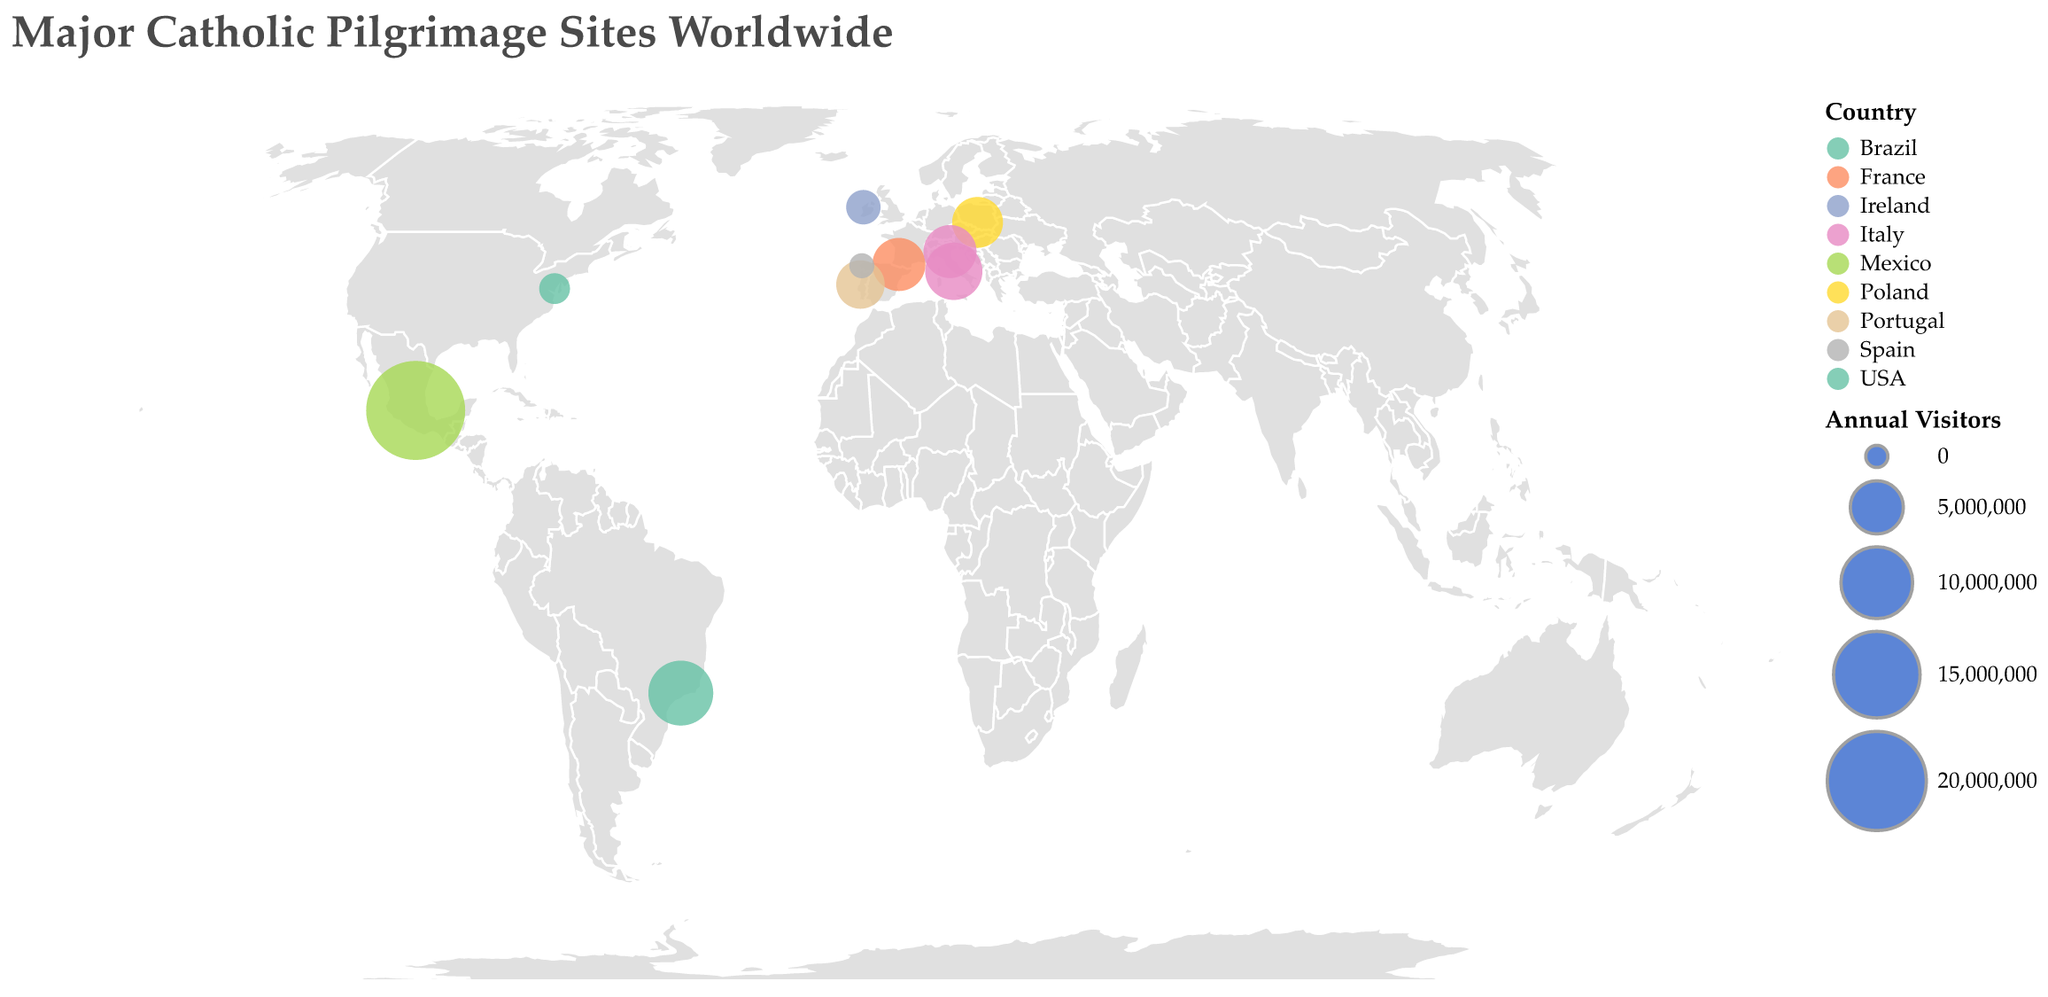What is the title of the plot? The title of the plot is often found at the top. Here, it is "Major Catholic Pilgrimage Sites Worldwide" as specified in the data provided.
Answer: Major Catholic Pilgrimage Sites Worldwide Which site has the highest number of annual visitors? By looking at the size of the circles in the plot, the largest circle would represent the site with the most visitors. According to the data, the Basilica of Our Lady of Guadalupe in Mexico has the largest annual visitors at 20,000,000.
Answer: Basilica of Our Lady of Guadalupe Which country has the most pilgrimage sites in the figure? Observing the color legend representing countries and counting the number of circles (pilgrimage sites) for each country helps in identifying this. Italy has two pilgrimage sites (Vatican City and Basilica of Saint Anthony).
Answer: Italy Which site receives more visitors, the Sanctuary of Fátima or the Sanctuary of Knock? Comparing the size of the circles or directly referring to the data values: Sanctuary of Fátima has 4,000,000 visitors, and Sanctuary of Knock has 1,500,000 visitors.
Answer: Sanctuary of Fátima What is the total number of annual visitors to the sites in Europe? Summing up the Annual_Visitors from the European sites (Vatican City, Sanctuary of Our Lady of Lourdes, Sanctuary of Fátima, Santiago de Compostela, Sanctuary of Knock, Shrine of Our Lady of Czestochowa, Basilica of Saint Anthony): 6,000,000 + 5,000,000 + 4,000,000 + 300,000 + 1,500,000 + 4,500,000 + 5,000,000 = 26,300,000.
Answer: 26,300,000 How does the annual visitor number of the Shrine of Our Lady of Aparecida compare to the Vatican City? Referring to the data values: Shrine of Our Lady of Aparecida has 8,000,000 visitors, while Vatican City has 6,000,000. Thus, the Shrine of Our Lady of Aparecida has 2,000,000 more visitors than Vatican City.
Answer: 2,000,000 more Identify the pilgrimage site in the Americas with the least annual visitors. Observing the data, the Basilica of the National Shrine of the Immaculate Conception (USA) has the least visitors in the Americas: 1,000,000 annual visitors.
Answer: Basilica of the National Shrine of the Immaculate Conception What is the average number of annual visitors per site? Adding the annual visitors of all sites and dividing by the number of sites: (6,000,000 + 5,000,000 + 20,000,000 + 4,000,000 + 300,000 + 1,500,000 + 1,000,000 + 4,500,000 + 5,000,000 + 8,000,000) / 10 = 55,300,000 / 10 = 5,530,000.
Answer: 5,530,000 How many pilgrimage sites are located in Latin America, according to the plot? From the plot, the Latin American countries listed are Mexico (Basilica of Our Lady of Guadalupe) and Brazil (Shrine of Our Lady of Aparecida), making it a total of 2 sites.
Answer: 2 Which pilgrimage site in Europe has the smallest number of annual visitors, and how many visitors does it receive? Referring to the data values, Santiago de Compostela in Spain has the smallest number of annual visitors among European sites, with 300,000 visitors.
Answer: Santiago de Compostela, 300,000 